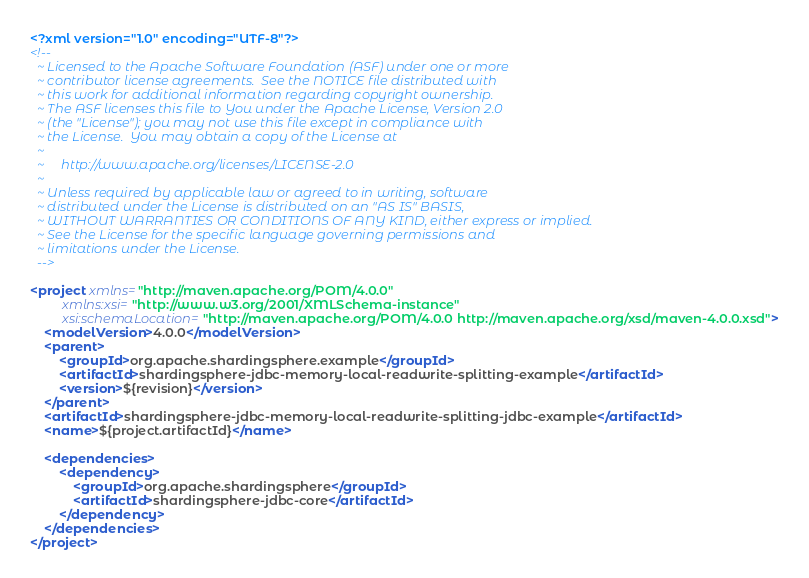<code> <loc_0><loc_0><loc_500><loc_500><_XML_><?xml version="1.0" encoding="UTF-8"?>
<!--
  ~ Licensed to the Apache Software Foundation (ASF) under one or more
  ~ contributor license agreements.  See the NOTICE file distributed with
  ~ this work for additional information regarding copyright ownership.
  ~ The ASF licenses this file to You under the Apache License, Version 2.0
  ~ (the "License"); you may not use this file except in compliance with
  ~ the License.  You may obtain a copy of the License at
  ~
  ~     http://www.apache.org/licenses/LICENSE-2.0
  ~
  ~ Unless required by applicable law or agreed to in writing, software
  ~ distributed under the License is distributed on an "AS IS" BASIS,
  ~ WITHOUT WARRANTIES OR CONDITIONS OF ANY KIND, either express or implied.
  ~ See the License for the specific language governing permissions and
  ~ limitations under the License.
  -->

<project xmlns="http://maven.apache.org/POM/4.0.0"
         xmlns:xsi="http://www.w3.org/2001/XMLSchema-instance"
         xsi:schemaLocation="http://maven.apache.org/POM/4.0.0 http://maven.apache.org/xsd/maven-4.0.0.xsd">
    <modelVersion>4.0.0</modelVersion>
    <parent>
        <groupId>org.apache.shardingsphere.example</groupId>
        <artifactId>shardingsphere-jdbc-memory-local-readwrite-splitting-example</artifactId>
        <version>${revision}</version>
    </parent>
    <artifactId>shardingsphere-jdbc-memory-local-readwrite-splitting-jdbc-example</artifactId>
    <name>${project.artifactId}</name>
    
    <dependencies>
        <dependency>
            <groupId>org.apache.shardingsphere</groupId>
            <artifactId>shardingsphere-jdbc-core</artifactId>
        </dependency>
    </dependencies>
</project>
</code> 